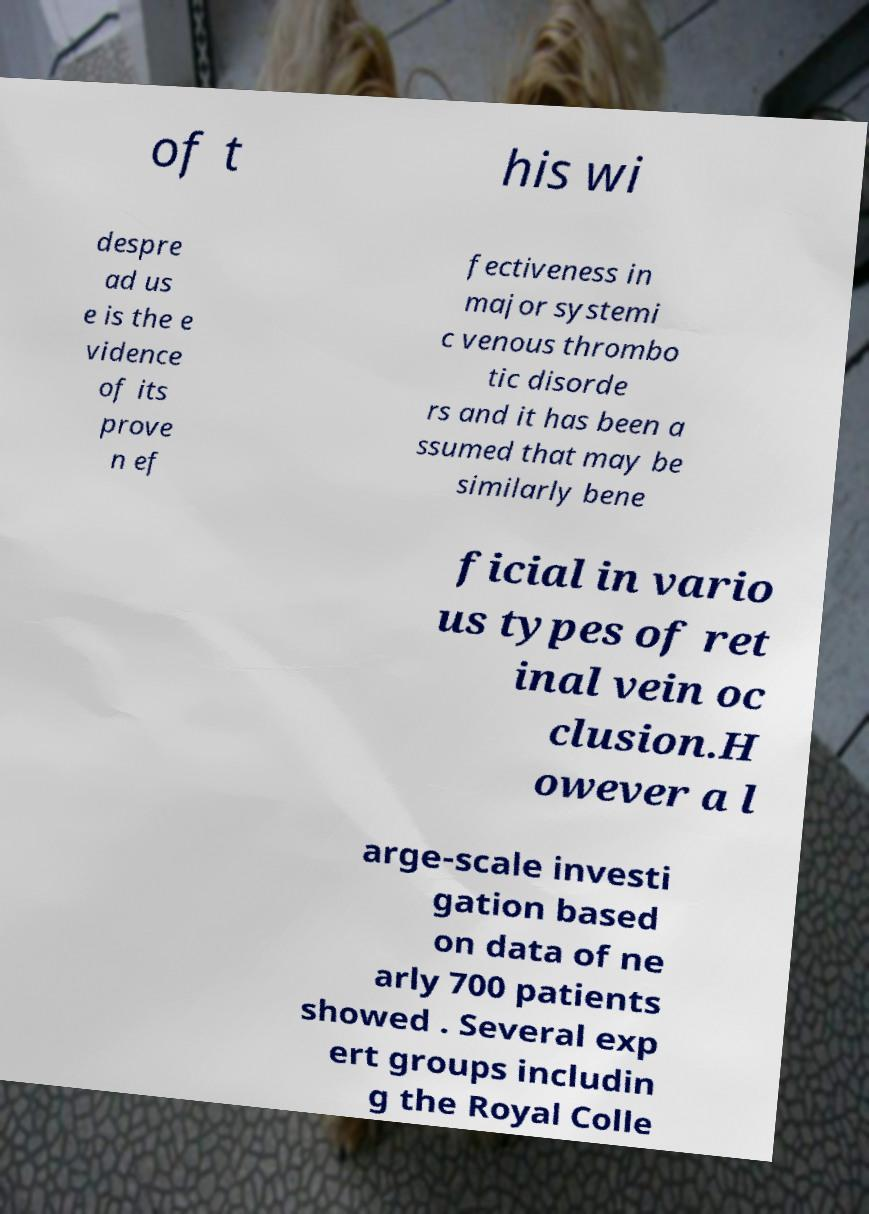What messages or text are displayed in this image? I need them in a readable, typed format. of t his wi despre ad us e is the e vidence of its prove n ef fectiveness in major systemi c venous thrombo tic disorde rs and it has been a ssumed that may be similarly bene ficial in vario us types of ret inal vein oc clusion.H owever a l arge-scale investi gation based on data of ne arly 700 patients showed . Several exp ert groups includin g the Royal Colle 